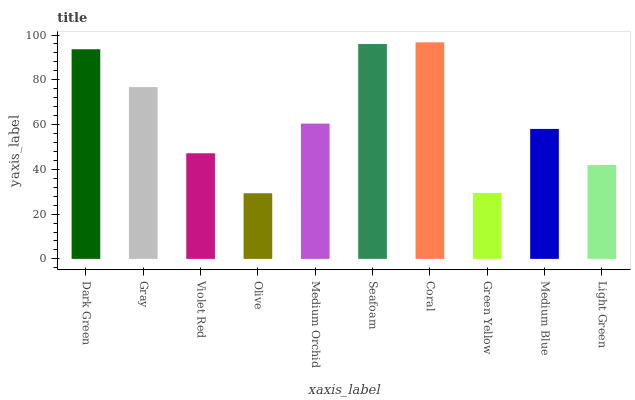Is Gray the minimum?
Answer yes or no. No. Is Gray the maximum?
Answer yes or no. No. Is Dark Green greater than Gray?
Answer yes or no. Yes. Is Gray less than Dark Green?
Answer yes or no. Yes. Is Gray greater than Dark Green?
Answer yes or no. No. Is Dark Green less than Gray?
Answer yes or no. No. Is Medium Orchid the high median?
Answer yes or no. Yes. Is Medium Blue the low median?
Answer yes or no. Yes. Is Coral the high median?
Answer yes or no. No. Is Green Yellow the low median?
Answer yes or no. No. 